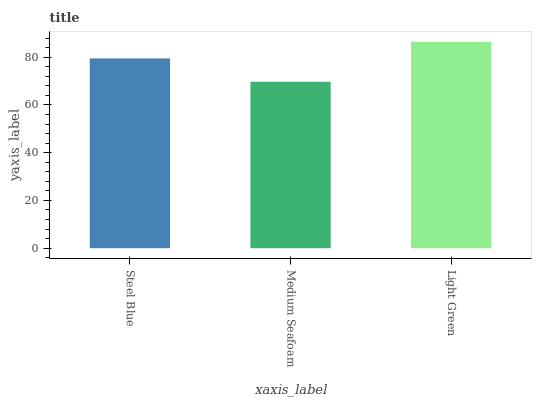Is Medium Seafoam the minimum?
Answer yes or no. Yes. Is Light Green the maximum?
Answer yes or no. Yes. Is Light Green the minimum?
Answer yes or no. No. Is Medium Seafoam the maximum?
Answer yes or no. No. Is Light Green greater than Medium Seafoam?
Answer yes or no. Yes. Is Medium Seafoam less than Light Green?
Answer yes or no. Yes. Is Medium Seafoam greater than Light Green?
Answer yes or no. No. Is Light Green less than Medium Seafoam?
Answer yes or no. No. Is Steel Blue the high median?
Answer yes or no. Yes. Is Steel Blue the low median?
Answer yes or no. Yes. Is Light Green the high median?
Answer yes or no. No. Is Medium Seafoam the low median?
Answer yes or no. No. 